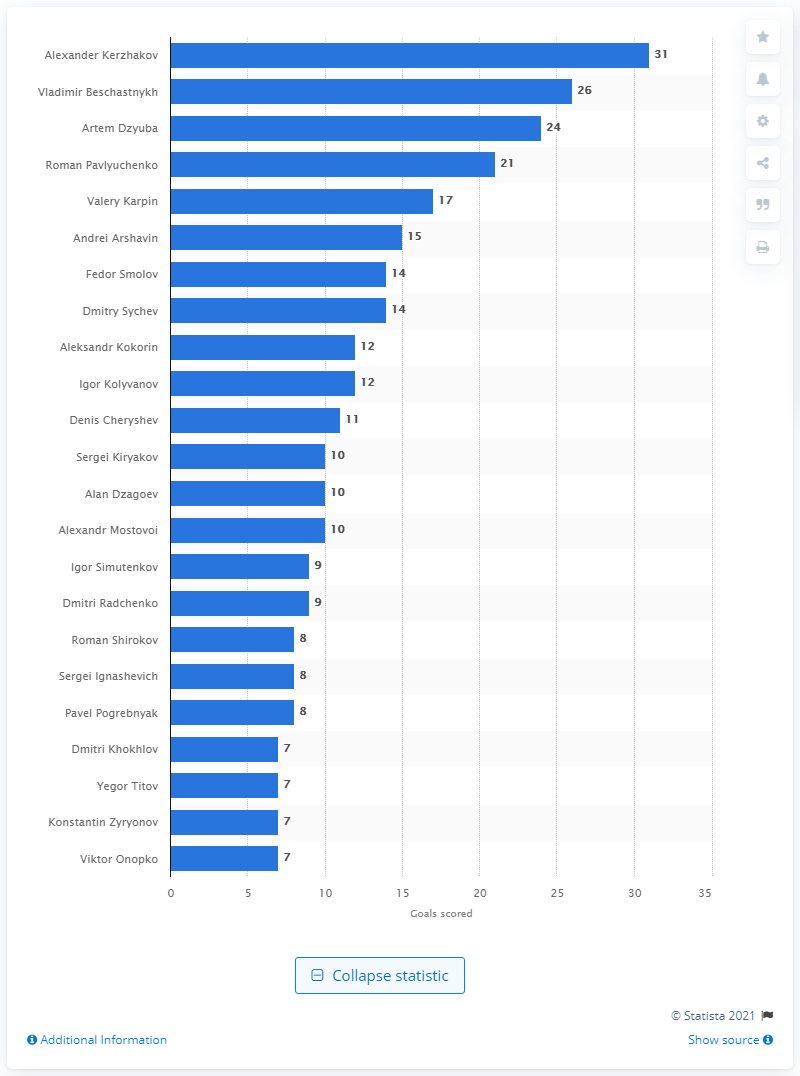Give some essential details in this illustration. Vladimir Beschastnykh is the second all-time leading scorer for the Russian national team. Alexander Kerzhakov is the all-time leading goal scorer for the national football team of Russia. 